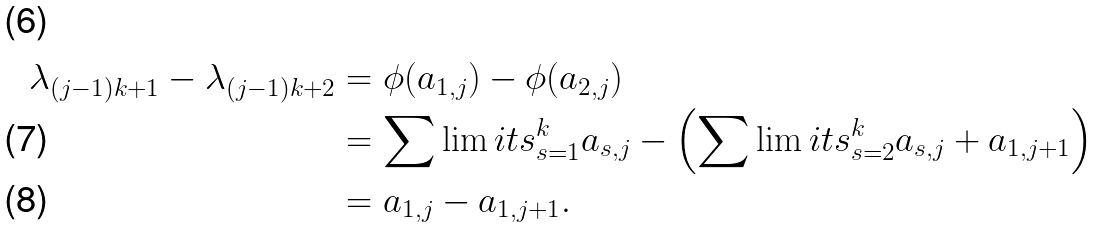Convert formula to latex. <formula><loc_0><loc_0><loc_500><loc_500>\lambda _ { ( j - 1 ) k + 1 } - \lambda _ { ( j - 1 ) k + 2 } & = \phi ( a _ { 1 , j } ) - \phi ( a _ { 2 , j } ) \\ & = \sum \lim i t s _ { s = 1 } ^ { k } a _ { s , j } - \left ( \sum \lim i t s _ { s = 2 } ^ { k } a _ { s , j } + a _ { 1 , j + 1 } \right ) \\ & = a _ { 1 , j } - a _ { 1 , j + 1 } .</formula> 